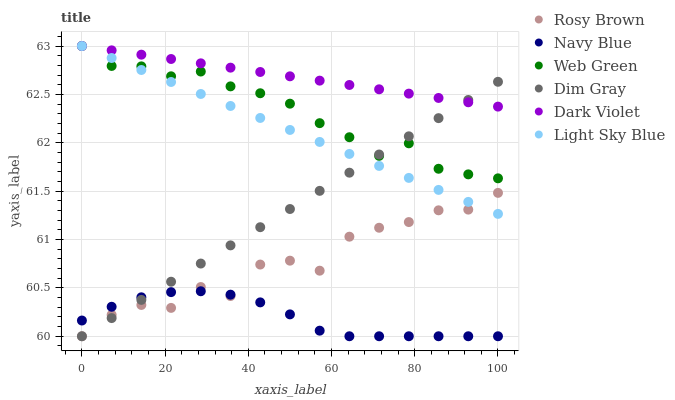Does Navy Blue have the minimum area under the curve?
Answer yes or no. Yes. Does Dark Violet have the maximum area under the curve?
Answer yes or no. Yes. Does Rosy Brown have the minimum area under the curve?
Answer yes or no. No. Does Rosy Brown have the maximum area under the curve?
Answer yes or no. No. Is Dark Violet the smoothest?
Answer yes or no. Yes. Is Rosy Brown the roughest?
Answer yes or no. Yes. Is Navy Blue the smoothest?
Answer yes or no. No. Is Navy Blue the roughest?
Answer yes or no. No. Does Dim Gray have the lowest value?
Answer yes or no. Yes. Does Dark Violet have the lowest value?
Answer yes or no. No. Does Web Green have the highest value?
Answer yes or no. Yes. Does Rosy Brown have the highest value?
Answer yes or no. No. Is Navy Blue less than Dark Violet?
Answer yes or no. Yes. Is Dark Violet greater than Navy Blue?
Answer yes or no. Yes. Does Dim Gray intersect Navy Blue?
Answer yes or no. Yes. Is Dim Gray less than Navy Blue?
Answer yes or no. No. Is Dim Gray greater than Navy Blue?
Answer yes or no. No. Does Navy Blue intersect Dark Violet?
Answer yes or no. No. 